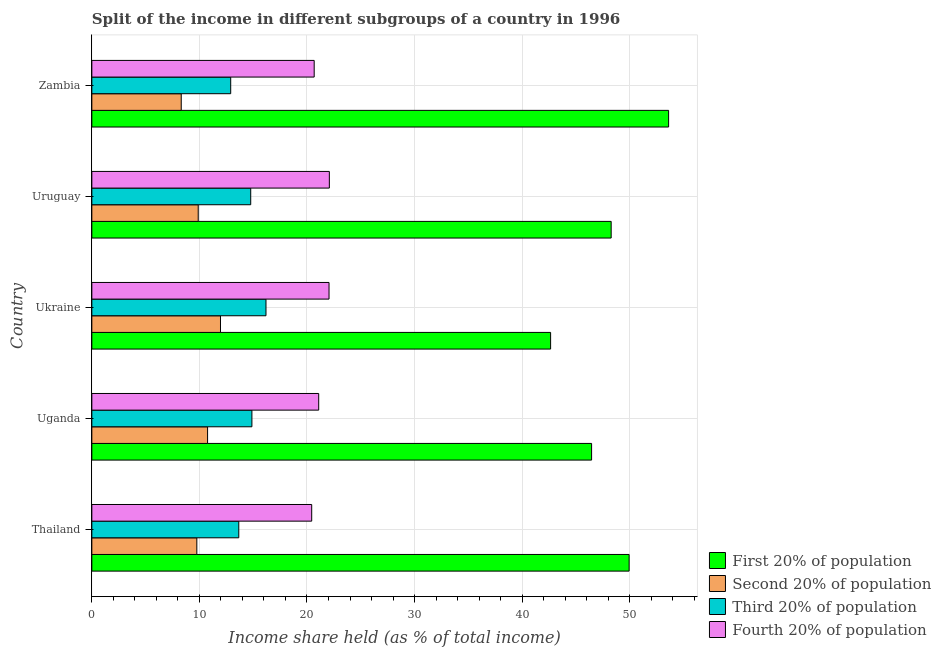How many groups of bars are there?
Offer a terse response. 5. Are the number of bars per tick equal to the number of legend labels?
Ensure brevity in your answer.  Yes. Are the number of bars on each tick of the Y-axis equal?
Provide a succinct answer. Yes. How many bars are there on the 2nd tick from the bottom?
Give a very brief answer. 4. What is the label of the 2nd group of bars from the top?
Provide a short and direct response. Uruguay. What is the share of the income held by first 20% of the population in Uganda?
Provide a succinct answer. 46.46. Across all countries, what is the maximum share of the income held by first 20% of the population?
Give a very brief answer. 53.62. Across all countries, what is the minimum share of the income held by fourth 20% of the population?
Your response must be concise. 20.44. In which country was the share of the income held by third 20% of the population maximum?
Offer a terse response. Ukraine. In which country was the share of the income held by second 20% of the population minimum?
Offer a very short reply. Zambia. What is the total share of the income held by fourth 20% of the population in the graph?
Your response must be concise. 106.33. What is the difference between the share of the income held by first 20% of the population in Thailand and that in Uruguay?
Offer a very short reply. 1.67. What is the difference between the share of the income held by second 20% of the population in Zambia and the share of the income held by fourth 20% of the population in Uganda?
Your response must be concise. -12.78. What is the average share of the income held by second 20% of the population per country?
Provide a succinct answer. 10.14. What is the difference between the share of the income held by third 20% of the population and share of the income held by first 20% of the population in Uganda?
Your response must be concise. -31.58. In how many countries, is the share of the income held by third 20% of the population greater than 34 %?
Your response must be concise. 0. What is the ratio of the share of the income held by fourth 20% of the population in Thailand to that in Ukraine?
Offer a very short reply. 0.93. Is the difference between the share of the income held by second 20% of the population in Uganda and Ukraine greater than the difference between the share of the income held by third 20% of the population in Uganda and Ukraine?
Your answer should be compact. Yes. What is the difference between the highest and the second highest share of the income held by second 20% of the population?
Make the answer very short. 1.2. What is the difference between the highest and the lowest share of the income held by third 20% of the population?
Your answer should be compact. 3.28. In how many countries, is the share of the income held by third 20% of the population greater than the average share of the income held by third 20% of the population taken over all countries?
Provide a short and direct response. 3. Is the sum of the share of the income held by second 20% of the population in Thailand and Uganda greater than the maximum share of the income held by fourth 20% of the population across all countries?
Make the answer very short. No. Is it the case that in every country, the sum of the share of the income held by fourth 20% of the population and share of the income held by third 20% of the population is greater than the sum of share of the income held by second 20% of the population and share of the income held by first 20% of the population?
Your response must be concise. Yes. What does the 3rd bar from the top in Uganda represents?
Your answer should be very brief. Second 20% of population. What does the 1st bar from the bottom in Uruguay represents?
Provide a succinct answer. First 20% of population. Is it the case that in every country, the sum of the share of the income held by first 20% of the population and share of the income held by second 20% of the population is greater than the share of the income held by third 20% of the population?
Keep it short and to the point. Yes. What is the difference between two consecutive major ticks on the X-axis?
Your answer should be compact. 10. How many legend labels are there?
Make the answer very short. 4. What is the title of the graph?
Your answer should be very brief. Split of the income in different subgroups of a country in 1996. Does "Arable land" appear as one of the legend labels in the graph?
Your response must be concise. No. What is the label or title of the X-axis?
Offer a very short reply. Income share held (as % of total income). What is the label or title of the Y-axis?
Make the answer very short. Country. What is the Income share held (as % of total income) of First 20% of population in Thailand?
Provide a short and direct response. 49.95. What is the Income share held (as % of total income) of Second 20% of population in Thailand?
Make the answer very short. 9.76. What is the Income share held (as % of total income) in Third 20% of population in Thailand?
Keep it short and to the point. 13.66. What is the Income share held (as % of total income) of Fourth 20% of population in Thailand?
Provide a succinct answer. 20.44. What is the Income share held (as % of total income) of First 20% of population in Uganda?
Your answer should be compact. 46.46. What is the Income share held (as % of total income) in Second 20% of population in Uganda?
Provide a succinct answer. 10.76. What is the Income share held (as % of total income) in Third 20% of population in Uganda?
Ensure brevity in your answer.  14.88. What is the Income share held (as % of total income) of Fourth 20% of population in Uganda?
Offer a terse response. 21.09. What is the Income share held (as % of total income) in First 20% of population in Ukraine?
Keep it short and to the point. 42.65. What is the Income share held (as % of total income) of Second 20% of population in Ukraine?
Your answer should be very brief. 11.96. What is the Income share held (as % of total income) in Third 20% of population in Ukraine?
Keep it short and to the point. 16.19. What is the Income share held (as % of total income) in Fourth 20% of population in Ukraine?
Give a very brief answer. 22.05. What is the Income share held (as % of total income) in First 20% of population in Uruguay?
Provide a short and direct response. 48.28. What is the Income share held (as % of total income) of Second 20% of population in Uruguay?
Your response must be concise. 9.89. What is the Income share held (as % of total income) of Third 20% of population in Uruguay?
Offer a very short reply. 14.77. What is the Income share held (as % of total income) in Fourth 20% of population in Uruguay?
Keep it short and to the point. 22.08. What is the Income share held (as % of total income) of First 20% of population in Zambia?
Provide a succinct answer. 53.62. What is the Income share held (as % of total income) of Second 20% of population in Zambia?
Provide a succinct answer. 8.31. What is the Income share held (as % of total income) of Third 20% of population in Zambia?
Your answer should be compact. 12.91. What is the Income share held (as % of total income) of Fourth 20% of population in Zambia?
Keep it short and to the point. 20.67. Across all countries, what is the maximum Income share held (as % of total income) in First 20% of population?
Your answer should be very brief. 53.62. Across all countries, what is the maximum Income share held (as % of total income) of Second 20% of population?
Your answer should be compact. 11.96. Across all countries, what is the maximum Income share held (as % of total income) of Third 20% of population?
Your answer should be very brief. 16.19. Across all countries, what is the maximum Income share held (as % of total income) of Fourth 20% of population?
Your answer should be compact. 22.08. Across all countries, what is the minimum Income share held (as % of total income) of First 20% of population?
Provide a succinct answer. 42.65. Across all countries, what is the minimum Income share held (as % of total income) of Second 20% of population?
Give a very brief answer. 8.31. Across all countries, what is the minimum Income share held (as % of total income) in Third 20% of population?
Offer a very short reply. 12.91. Across all countries, what is the minimum Income share held (as % of total income) of Fourth 20% of population?
Your response must be concise. 20.44. What is the total Income share held (as % of total income) in First 20% of population in the graph?
Your response must be concise. 240.96. What is the total Income share held (as % of total income) in Second 20% of population in the graph?
Ensure brevity in your answer.  50.68. What is the total Income share held (as % of total income) of Third 20% of population in the graph?
Your answer should be compact. 72.41. What is the total Income share held (as % of total income) in Fourth 20% of population in the graph?
Offer a terse response. 106.33. What is the difference between the Income share held (as % of total income) of First 20% of population in Thailand and that in Uganda?
Ensure brevity in your answer.  3.49. What is the difference between the Income share held (as % of total income) of Second 20% of population in Thailand and that in Uganda?
Make the answer very short. -1. What is the difference between the Income share held (as % of total income) of Third 20% of population in Thailand and that in Uganda?
Ensure brevity in your answer.  -1.22. What is the difference between the Income share held (as % of total income) of Fourth 20% of population in Thailand and that in Uganda?
Make the answer very short. -0.65. What is the difference between the Income share held (as % of total income) of Second 20% of population in Thailand and that in Ukraine?
Provide a succinct answer. -2.2. What is the difference between the Income share held (as % of total income) of Third 20% of population in Thailand and that in Ukraine?
Ensure brevity in your answer.  -2.53. What is the difference between the Income share held (as % of total income) in Fourth 20% of population in Thailand and that in Ukraine?
Offer a very short reply. -1.61. What is the difference between the Income share held (as % of total income) of First 20% of population in Thailand and that in Uruguay?
Offer a terse response. 1.67. What is the difference between the Income share held (as % of total income) in Second 20% of population in Thailand and that in Uruguay?
Offer a terse response. -0.13. What is the difference between the Income share held (as % of total income) of Third 20% of population in Thailand and that in Uruguay?
Keep it short and to the point. -1.11. What is the difference between the Income share held (as % of total income) of Fourth 20% of population in Thailand and that in Uruguay?
Provide a succinct answer. -1.64. What is the difference between the Income share held (as % of total income) of First 20% of population in Thailand and that in Zambia?
Ensure brevity in your answer.  -3.67. What is the difference between the Income share held (as % of total income) of Second 20% of population in Thailand and that in Zambia?
Give a very brief answer. 1.45. What is the difference between the Income share held (as % of total income) in Fourth 20% of population in Thailand and that in Zambia?
Ensure brevity in your answer.  -0.23. What is the difference between the Income share held (as % of total income) in First 20% of population in Uganda and that in Ukraine?
Give a very brief answer. 3.81. What is the difference between the Income share held (as % of total income) of Third 20% of population in Uganda and that in Ukraine?
Your response must be concise. -1.31. What is the difference between the Income share held (as % of total income) in Fourth 20% of population in Uganda and that in Ukraine?
Your answer should be very brief. -0.96. What is the difference between the Income share held (as % of total income) in First 20% of population in Uganda and that in Uruguay?
Make the answer very short. -1.82. What is the difference between the Income share held (as % of total income) of Second 20% of population in Uganda and that in Uruguay?
Make the answer very short. 0.87. What is the difference between the Income share held (as % of total income) of Third 20% of population in Uganda and that in Uruguay?
Offer a very short reply. 0.11. What is the difference between the Income share held (as % of total income) in Fourth 20% of population in Uganda and that in Uruguay?
Your answer should be compact. -0.99. What is the difference between the Income share held (as % of total income) of First 20% of population in Uganda and that in Zambia?
Offer a terse response. -7.16. What is the difference between the Income share held (as % of total income) in Second 20% of population in Uganda and that in Zambia?
Your response must be concise. 2.45. What is the difference between the Income share held (as % of total income) of Third 20% of population in Uganda and that in Zambia?
Give a very brief answer. 1.97. What is the difference between the Income share held (as % of total income) in Fourth 20% of population in Uganda and that in Zambia?
Your answer should be very brief. 0.42. What is the difference between the Income share held (as % of total income) of First 20% of population in Ukraine and that in Uruguay?
Keep it short and to the point. -5.63. What is the difference between the Income share held (as % of total income) in Second 20% of population in Ukraine and that in Uruguay?
Provide a succinct answer. 2.07. What is the difference between the Income share held (as % of total income) of Third 20% of population in Ukraine and that in Uruguay?
Provide a succinct answer. 1.42. What is the difference between the Income share held (as % of total income) in Fourth 20% of population in Ukraine and that in Uruguay?
Your answer should be compact. -0.03. What is the difference between the Income share held (as % of total income) in First 20% of population in Ukraine and that in Zambia?
Ensure brevity in your answer.  -10.97. What is the difference between the Income share held (as % of total income) of Second 20% of population in Ukraine and that in Zambia?
Ensure brevity in your answer.  3.65. What is the difference between the Income share held (as % of total income) in Third 20% of population in Ukraine and that in Zambia?
Ensure brevity in your answer.  3.28. What is the difference between the Income share held (as % of total income) of Fourth 20% of population in Ukraine and that in Zambia?
Your answer should be compact. 1.38. What is the difference between the Income share held (as % of total income) in First 20% of population in Uruguay and that in Zambia?
Offer a terse response. -5.34. What is the difference between the Income share held (as % of total income) of Second 20% of population in Uruguay and that in Zambia?
Provide a short and direct response. 1.58. What is the difference between the Income share held (as % of total income) in Third 20% of population in Uruguay and that in Zambia?
Your answer should be compact. 1.86. What is the difference between the Income share held (as % of total income) in Fourth 20% of population in Uruguay and that in Zambia?
Offer a terse response. 1.41. What is the difference between the Income share held (as % of total income) in First 20% of population in Thailand and the Income share held (as % of total income) in Second 20% of population in Uganda?
Ensure brevity in your answer.  39.19. What is the difference between the Income share held (as % of total income) in First 20% of population in Thailand and the Income share held (as % of total income) in Third 20% of population in Uganda?
Your answer should be very brief. 35.07. What is the difference between the Income share held (as % of total income) of First 20% of population in Thailand and the Income share held (as % of total income) of Fourth 20% of population in Uganda?
Your answer should be compact. 28.86. What is the difference between the Income share held (as % of total income) of Second 20% of population in Thailand and the Income share held (as % of total income) of Third 20% of population in Uganda?
Give a very brief answer. -5.12. What is the difference between the Income share held (as % of total income) in Second 20% of population in Thailand and the Income share held (as % of total income) in Fourth 20% of population in Uganda?
Offer a very short reply. -11.33. What is the difference between the Income share held (as % of total income) in Third 20% of population in Thailand and the Income share held (as % of total income) in Fourth 20% of population in Uganda?
Make the answer very short. -7.43. What is the difference between the Income share held (as % of total income) of First 20% of population in Thailand and the Income share held (as % of total income) of Second 20% of population in Ukraine?
Your answer should be compact. 37.99. What is the difference between the Income share held (as % of total income) of First 20% of population in Thailand and the Income share held (as % of total income) of Third 20% of population in Ukraine?
Keep it short and to the point. 33.76. What is the difference between the Income share held (as % of total income) in First 20% of population in Thailand and the Income share held (as % of total income) in Fourth 20% of population in Ukraine?
Your response must be concise. 27.9. What is the difference between the Income share held (as % of total income) in Second 20% of population in Thailand and the Income share held (as % of total income) in Third 20% of population in Ukraine?
Provide a short and direct response. -6.43. What is the difference between the Income share held (as % of total income) in Second 20% of population in Thailand and the Income share held (as % of total income) in Fourth 20% of population in Ukraine?
Offer a very short reply. -12.29. What is the difference between the Income share held (as % of total income) in Third 20% of population in Thailand and the Income share held (as % of total income) in Fourth 20% of population in Ukraine?
Keep it short and to the point. -8.39. What is the difference between the Income share held (as % of total income) in First 20% of population in Thailand and the Income share held (as % of total income) in Second 20% of population in Uruguay?
Your response must be concise. 40.06. What is the difference between the Income share held (as % of total income) in First 20% of population in Thailand and the Income share held (as % of total income) in Third 20% of population in Uruguay?
Offer a very short reply. 35.18. What is the difference between the Income share held (as % of total income) in First 20% of population in Thailand and the Income share held (as % of total income) in Fourth 20% of population in Uruguay?
Offer a terse response. 27.87. What is the difference between the Income share held (as % of total income) in Second 20% of population in Thailand and the Income share held (as % of total income) in Third 20% of population in Uruguay?
Your response must be concise. -5.01. What is the difference between the Income share held (as % of total income) of Second 20% of population in Thailand and the Income share held (as % of total income) of Fourth 20% of population in Uruguay?
Offer a very short reply. -12.32. What is the difference between the Income share held (as % of total income) of Third 20% of population in Thailand and the Income share held (as % of total income) of Fourth 20% of population in Uruguay?
Provide a succinct answer. -8.42. What is the difference between the Income share held (as % of total income) of First 20% of population in Thailand and the Income share held (as % of total income) of Second 20% of population in Zambia?
Your answer should be very brief. 41.64. What is the difference between the Income share held (as % of total income) of First 20% of population in Thailand and the Income share held (as % of total income) of Third 20% of population in Zambia?
Offer a very short reply. 37.04. What is the difference between the Income share held (as % of total income) in First 20% of population in Thailand and the Income share held (as % of total income) in Fourth 20% of population in Zambia?
Your response must be concise. 29.28. What is the difference between the Income share held (as % of total income) of Second 20% of population in Thailand and the Income share held (as % of total income) of Third 20% of population in Zambia?
Provide a succinct answer. -3.15. What is the difference between the Income share held (as % of total income) in Second 20% of population in Thailand and the Income share held (as % of total income) in Fourth 20% of population in Zambia?
Keep it short and to the point. -10.91. What is the difference between the Income share held (as % of total income) of Third 20% of population in Thailand and the Income share held (as % of total income) of Fourth 20% of population in Zambia?
Keep it short and to the point. -7.01. What is the difference between the Income share held (as % of total income) in First 20% of population in Uganda and the Income share held (as % of total income) in Second 20% of population in Ukraine?
Offer a terse response. 34.5. What is the difference between the Income share held (as % of total income) in First 20% of population in Uganda and the Income share held (as % of total income) in Third 20% of population in Ukraine?
Make the answer very short. 30.27. What is the difference between the Income share held (as % of total income) in First 20% of population in Uganda and the Income share held (as % of total income) in Fourth 20% of population in Ukraine?
Make the answer very short. 24.41. What is the difference between the Income share held (as % of total income) of Second 20% of population in Uganda and the Income share held (as % of total income) of Third 20% of population in Ukraine?
Make the answer very short. -5.43. What is the difference between the Income share held (as % of total income) of Second 20% of population in Uganda and the Income share held (as % of total income) of Fourth 20% of population in Ukraine?
Your answer should be compact. -11.29. What is the difference between the Income share held (as % of total income) of Third 20% of population in Uganda and the Income share held (as % of total income) of Fourth 20% of population in Ukraine?
Give a very brief answer. -7.17. What is the difference between the Income share held (as % of total income) of First 20% of population in Uganda and the Income share held (as % of total income) of Second 20% of population in Uruguay?
Make the answer very short. 36.57. What is the difference between the Income share held (as % of total income) in First 20% of population in Uganda and the Income share held (as % of total income) in Third 20% of population in Uruguay?
Your response must be concise. 31.69. What is the difference between the Income share held (as % of total income) in First 20% of population in Uganda and the Income share held (as % of total income) in Fourth 20% of population in Uruguay?
Keep it short and to the point. 24.38. What is the difference between the Income share held (as % of total income) of Second 20% of population in Uganda and the Income share held (as % of total income) of Third 20% of population in Uruguay?
Offer a very short reply. -4.01. What is the difference between the Income share held (as % of total income) in Second 20% of population in Uganda and the Income share held (as % of total income) in Fourth 20% of population in Uruguay?
Offer a terse response. -11.32. What is the difference between the Income share held (as % of total income) in First 20% of population in Uganda and the Income share held (as % of total income) in Second 20% of population in Zambia?
Provide a short and direct response. 38.15. What is the difference between the Income share held (as % of total income) in First 20% of population in Uganda and the Income share held (as % of total income) in Third 20% of population in Zambia?
Ensure brevity in your answer.  33.55. What is the difference between the Income share held (as % of total income) of First 20% of population in Uganda and the Income share held (as % of total income) of Fourth 20% of population in Zambia?
Your answer should be compact. 25.79. What is the difference between the Income share held (as % of total income) in Second 20% of population in Uganda and the Income share held (as % of total income) in Third 20% of population in Zambia?
Your response must be concise. -2.15. What is the difference between the Income share held (as % of total income) in Second 20% of population in Uganda and the Income share held (as % of total income) in Fourth 20% of population in Zambia?
Provide a short and direct response. -9.91. What is the difference between the Income share held (as % of total income) in Third 20% of population in Uganda and the Income share held (as % of total income) in Fourth 20% of population in Zambia?
Provide a short and direct response. -5.79. What is the difference between the Income share held (as % of total income) in First 20% of population in Ukraine and the Income share held (as % of total income) in Second 20% of population in Uruguay?
Make the answer very short. 32.76. What is the difference between the Income share held (as % of total income) of First 20% of population in Ukraine and the Income share held (as % of total income) of Third 20% of population in Uruguay?
Your response must be concise. 27.88. What is the difference between the Income share held (as % of total income) of First 20% of population in Ukraine and the Income share held (as % of total income) of Fourth 20% of population in Uruguay?
Your answer should be compact. 20.57. What is the difference between the Income share held (as % of total income) in Second 20% of population in Ukraine and the Income share held (as % of total income) in Third 20% of population in Uruguay?
Offer a terse response. -2.81. What is the difference between the Income share held (as % of total income) in Second 20% of population in Ukraine and the Income share held (as % of total income) in Fourth 20% of population in Uruguay?
Your answer should be compact. -10.12. What is the difference between the Income share held (as % of total income) of Third 20% of population in Ukraine and the Income share held (as % of total income) of Fourth 20% of population in Uruguay?
Offer a terse response. -5.89. What is the difference between the Income share held (as % of total income) in First 20% of population in Ukraine and the Income share held (as % of total income) in Second 20% of population in Zambia?
Provide a succinct answer. 34.34. What is the difference between the Income share held (as % of total income) in First 20% of population in Ukraine and the Income share held (as % of total income) in Third 20% of population in Zambia?
Provide a succinct answer. 29.74. What is the difference between the Income share held (as % of total income) in First 20% of population in Ukraine and the Income share held (as % of total income) in Fourth 20% of population in Zambia?
Ensure brevity in your answer.  21.98. What is the difference between the Income share held (as % of total income) of Second 20% of population in Ukraine and the Income share held (as % of total income) of Third 20% of population in Zambia?
Provide a succinct answer. -0.95. What is the difference between the Income share held (as % of total income) of Second 20% of population in Ukraine and the Income share held (as % of total income) of Fourth 20% of population in Zambia?
Offer a very short reply. -8.71. What is the difference between the Income share held (as % of total income) in Third 20% of population in Ukraine and the Income share held (as % of total income) in Fourth 20% of population in Zambia?
Provide a short and direct response. -4.48. What is the difference between the Income share held (as % of total income) of First 20% of population in Uruguay and the Income share held (as % of total income) of Second 20% of population in Zambia?
Offer a very short reply. 39.97. What is the difference between the Income share held (as % of total income) in First 20% of population in Uruguay and the Income share held (as % of total income) in Third 20% of population in Zambia?
Keep it short and to the point. 35.37. What is the difference between the Income share held (as % of total income) in First 20% of population in Uruguay and the Income share held (as % of total income) in Fourth 20% of population in Zambia?
Your response must be concise. 27.61. What is the difference between the Income share held (as % of total income) of Second 20% of population in Uruguay and the Income share held (as % of total income) of Third 20% of population in Zambia?
Your response must be concise. -3.02. What is the difference between the Income share held (as % of total income) of Second 20% of population in Uruguay and the Income share held (as % of total income) of Fourth 20% of population in Zambia?
Ensure brevity in your answer.  -10.78. What is the average Income share held (as % of total income) in First 20% of population per country?
Provide a short and direct response. 48.19. What is the average Income share held (as % of total income) in Second 20% of population per country?
Your answer should be very brief. 10.14. What is the average Income share held (as % of total income) in Third 20% of population per country?
Offer a very short reply. 14.48. What is the average Income share held (as % of total income) of Fourth 20% of population per country?
Offer a terse response. 21.27. What is the difference between the Income share held (as % of total income) in First 20% of population and Income share held (as % of total income) in Second 20% of population in Thailand?
Provide a short and direct response. 40.19. What is the difference between the Income share held (as % of total income) in First 20% of population and Income share held (as % of total income) in Third 20% of population in Thailand?
Ensure brevity in your answer.  36.29. What is the difference between the Income share held (as % of total income) of First 20% of population and Income share held (as % of total income) of Fourth 20% of population in Thailand?
Make the answer very short. 29.51. What is the difference between the Income share held (as % of total income) in Second 20% of population and Income share held (as % of total income) in Fourth 20% of population in Thailand?
Keep it short and to the point. -10.68. What is the difference between the Income share held (as % of total income) in Third 20% of population and Income share held (as % of total income) in Fourth 20% of population in Thailand?
Give a very brief answer. -6.78. What is the difference between the Income share held (as % of total income) of First 20% of population and Income share held (as % of total income) of Second 20% of population in Uganda?
Your response must be concise. 35.7. What is the difference between the Income share held (as % of total income) of First 20% of population and Income share held (as % of total income) of Third 20% of population in Uganda?
Your answer should be compact. 31.58. What is the difference between the Income share held (as % of total income) in First 20% of population and Income share held (as % of total income) in Fourth 20% of population in Uganda?
Your answer should be compact. 25.37. What is the difference between the Income share held (as % of total income) in Second 20% of population and Income share held (as % of total income) in Third 20% of population in Uganda?
Make the answer very short. -4.12. What is the difference between the Income share held (as % of total income) of Second 20% of population and Income share held (as % of total income) of Fourth 20% of population in Uganda?
Provide a succinct answer. -10.33. What is the difference between the Income share held (as % of total income) in Third 20% of population and Income share held (as % of total income) in Fourth 20% of population in Uganda?
Your response must be concise. -6.21. What is the difference between the Income share held (as % of total income) in First 20% of population and Income share held (as % of total income) in Second 20% of population in Ukraine?
Provide a short and direct response. 30.69. What is the difference between the Income share held (as % of total income) in First 20% of population and Income share held (as % of total income) in Third 20% of population in Ukraine?
Provide a succinct answer. 26.46. What is the difference between the Income share held (as % of total income) in First 20% of population and Income share held (as % of total income) in Fourth 20% of population in Ukraine?
Provide a short and direct response. 20.6. What is the difference between the Income share held (as % of total income) in Second 20% of population and Income share held (as % of total income) in Third 20% of population in Ukraine?
Keep it short and to the point. -4.23. What is the difference between the Income share held (as % of total income) of Second 20% of population and Income share held (as % of total income) of Fourth 20% of population in Ukraine?
Give a very brief answer. -10.09. What is the difference between the Income share held (as % of total income) in Third 20% of population and Income share held (as % of total income) in Fourth 20% of population in Ukraine?
Your response must be concise. -5.86. What is the difference between the Income share held (as % of total income) of First 20% of population and Income share held (as % of total income) of Second 20% of population in Uruguay?
Provide a succinct answer. 38.39. What is the difference between the Income share held (as % of total income) of First 20% of population and Income share held (as % of total income) of Third 20% of population in Uruguay?
Ensure brevity in your answer.  33.51. What is the difference between the Income share held (as % of total income) in First 20% of population and Income share held (as % of total income) in Fourth 20% of population in Uruguay?
Provide a succinct answer. 26.2. What is the difference between the Income share held (as % of total income) of Second 20% of population and Income share held (as % of total income) of Third 20% of population in Uruguay?
Provide a succinct answer. -4.88. What is the difference between the Income share held (as % of total income) of Second 20% of population and Income share held (as % of total income) of Fourth 20% of population in Uruguay?
Give a very brief answer. -12.19. What is the difference between the Income share held (as % of total income) in Third 20% of population and Income share held (as % of total income) in Fourth 20% of population in Uruguay?
Your response must be concise. -7.31. What is the difference between the Income share held (as % of total income) of First 20% of population and Income share held (as % of total income) of Second 20% of population in Zambia?
Keep it short and to the point. 45.31. What is the difference between the Income share held (as % of total income) in First 20% of population and Income share held (as % of total income) in Third 20% of population in Zambia?
Your answer should be compact. 40.71. What is the difference between the Income share held (as % of total income) of First 20% of population and Income share held (as % of total income) of Fourth 20% of population in Zambia?
Give a very brief answer. 32.95. What is the difference between the Income share held (as % of total income) of Second 20% of population and Income share held (as % of total income) of Fourth 20% of population in Zambia?
Make the answer very short. -12.36. What is the difference between the Income share held (as % of total income) in Third 20% of population and Income share held (as % of total income) in Fourth 20% of population in Zambia?
Your response must be concise. -7.76. What is the ratio of the Income share held (as % of total income) in First 20% of population in Thailand to that in Uganda?
Your answer should be very brief. 1.08. What is the ratio of the Income share held (as % of total income) in Second 20% of population in Thailand to that in Uganda?
Provide a short and direct response. 0.91. What is the ratio of the Income share held (as % of total income) in Third 20% of population in Thailand to that in Uganda?
Your response must be concise. 0.92. What is the ratio of the Income share held (as % of total income) in Fourth 20% of population in Thailand to that in Uganda?
Your answer should be very brief. 0.97. What is the ratio of the Income share held (as % of total income) of First 20% of population in Thailand to that in Ukraine?
Offer a terse response. 1.17. What is the ratio of the Income share held (as % of total income) in Second 20% of population in Thailand to that in Ukraine?
Provide a short and direct response. 0.82. What is the ratio of the Income share held (as % of total income) of Third 20% of population in Thailand to that in Ukraine?
Your answer should be compact. 0.84. What is the ratio of the Income share held (as % of total income) in Fourth 20% of population in Thailand to that in Ukraine?
Your answer should be compact. 0.93. What is the ratio of the Income share held (as % of total income) in First 20% of population in Thailand to that in Uruguay?
Provide a short and direct response. 1.03. What is the ratio of the Income share held (as % of total income) in Second 20% of population in Thailand to that in Uruguay?
Offer a very short reply. 0.99. What is the ratio of the Income share held (as % of total income) in Third 20% of population in Thailand to that in Uruguay?
Offer a terse response. 0.92. What is the ratio of the Income share held (as % of total income) in Fourth 20% of population in Thailand to that in Uruguay?
Your answer should be very brief. 0.93. What is the ratio of the Income share held (as % of total income) of First 20% of population in Thailand to that in Zambia?
Provide a short and direct response. 0.93. What is the ratio of the Income share held (as % of total income) in Second 20% of population in Thailand to that in Zambia?
Your answer should be very brief. 1.17. What is the ratio of the Income share held (as % of total income) of Third 20% of population in Thailand to that in Zambia?
Give a very brief answer. 1.06. What is the ratio of the Income share held (as % of total income) of Fourth 20% of population in Thailand to that in Zambia?
Offer a terse response. 0.99. What is the ratio of the Income share held (as % of total income) of First 20% of population in Uganda to that in Ukraine?
Your answer should be compact. 1.09. What is the ratio of the Income share held (as % of total income) in Second 20% of population in Uganda to that in Ukraine?
Your response must be concise. 0.9. What is the ratio of the Income share held (as % of total income) of Third 20% of population in Uganda to that in Ukraine?
Offer a very short reply. 0.92. What is the ratio of the Income share held (as % of total income) of Fourth 20% of population in Uganda to that in Ukraine?
Provide a succinct answer. 0.96. What is the ratio of the Income share held (as % of total income) in First 20% of population in Uganda to that in Uruguay?
Provide a short and direct response. 0.96. What is the ratio of the Income share held (as % of total income) in Second 20% of population in Uganda to that in Uruguay?
Make the answer very short. 1.09. What is the ratio of the Income share held (as % of total income) in Third 20% of population in Uganda to that in Uruguay?
Your answer should be compact. 1.01. What is the ratio of the Income share held (as % of total income) in Fourth 20% of population in Uganda to that in Uruguay?
Offer a terse response. 0.96. What is the ratio of the Income share held (as % of total income) in First 20% of population in Uganda to that in Zambia?
Your answer should be very brief. 0.87. What is the ratio of the Income share held (as % of total income) of Second 20% of population in Uganda to that in Zambia?
Your response must be concise. 1.29. What is the ratio of the Income share held (as % of total income) of Third 20% of population in Uganda to that in Zambia?
Your answer should be very brief. 1.15. What is the ratio of the Income share held (as % of total income) in Fourth 20% of population in Uganda to that in Zambia?
Give a very brief answer. 1.02. What is the ratio of the Income share held (as % of total income) in First 20% of population in Ukraine to that in Uruguay?
Provide a succinct answer. 0.88. What is the ratio of the Income share held (as % of total income) in Second 20% of population in Ukraine to that in Uruguay?
Give a very brief answer. 1.21. What is the ratio of the Income share held (as % of total income) of Third 20% of population in Ukraine to that in Uruguay?
Offer a terse response. 1.1. What is the ratio of the Income share held (as % of total income) of First 20% of population in Ukraine to that in Zambia?
Give a very brief answer. 0.8. What is the ratio of the Income share held (as % of total income) in Second 20% of population in Ukraine to that in Zambia?
Your response must be concise. 1.44. What is the ratio of the Income share held (as % of total income) in Third 20% of population in Ukraine to that in Zambia?
Offer a terse response. 1.25. What is the ratio of the Income share held (as % of total income) of Fourth 20% of population in Ukraine to that in Zambia?
Provide a succinct answer. 1.07. What is the ratio of the Income share held (as % of total income) of First 20% of population in Uruguay to that in Zambia?
Your answer should be very brief. 0.9. What is the ratio of the Income share held (as % of total income) in Second 20% of population in Uruguay to that in Zambia?
Ensure brevity in your answer.  1.19. What is the ratio of the Income share held (as % of total income) in Third 20% of population in Uruguay to that in Zambia?
Your answer should be very brief. 1.14. What is the ratio of the Income share held (as % of total income) in Fourth 20% of population in Uruguay to that in Zambia?
Make the answer very short. 1.07. What is the difference between the highest and the second highest Income share held (as % of total income) of First 20% of population?
Give a very brief answer. 3.67. What is the difference between the highest and the second highest Income share held (as % of total income) of Second 20% of population?
Ensure brevity in your answer.  1.2. What is the difference between the highest and the second highest Income share held (as % of total income) in Third 20% of population?
Keep it short and to the point. 1.31. What is the difference between the highest and the second highest Income share held (as % of total income) in Fourth 20% of population?
Your response must be concise. 0.03. What is the difference between the highest and the lowest Income share held (as % of total income) in First 20% of population?
Your answer should be very brief. 10.97. What is the difference between the highest and the lowest Income share held (as % of total income) in Second 20% of population?
Provide a succinct answer. 3.65. What is the difference between the highest and the lowest Income share held (as % of total income) in Third 20% of population?
Keep it short and to the point. 3.28. What is the difference between the highest and the lowest Income share held (as % of total income) in Fourth 20% of population?
Your answer should be very brief. 1.64. 